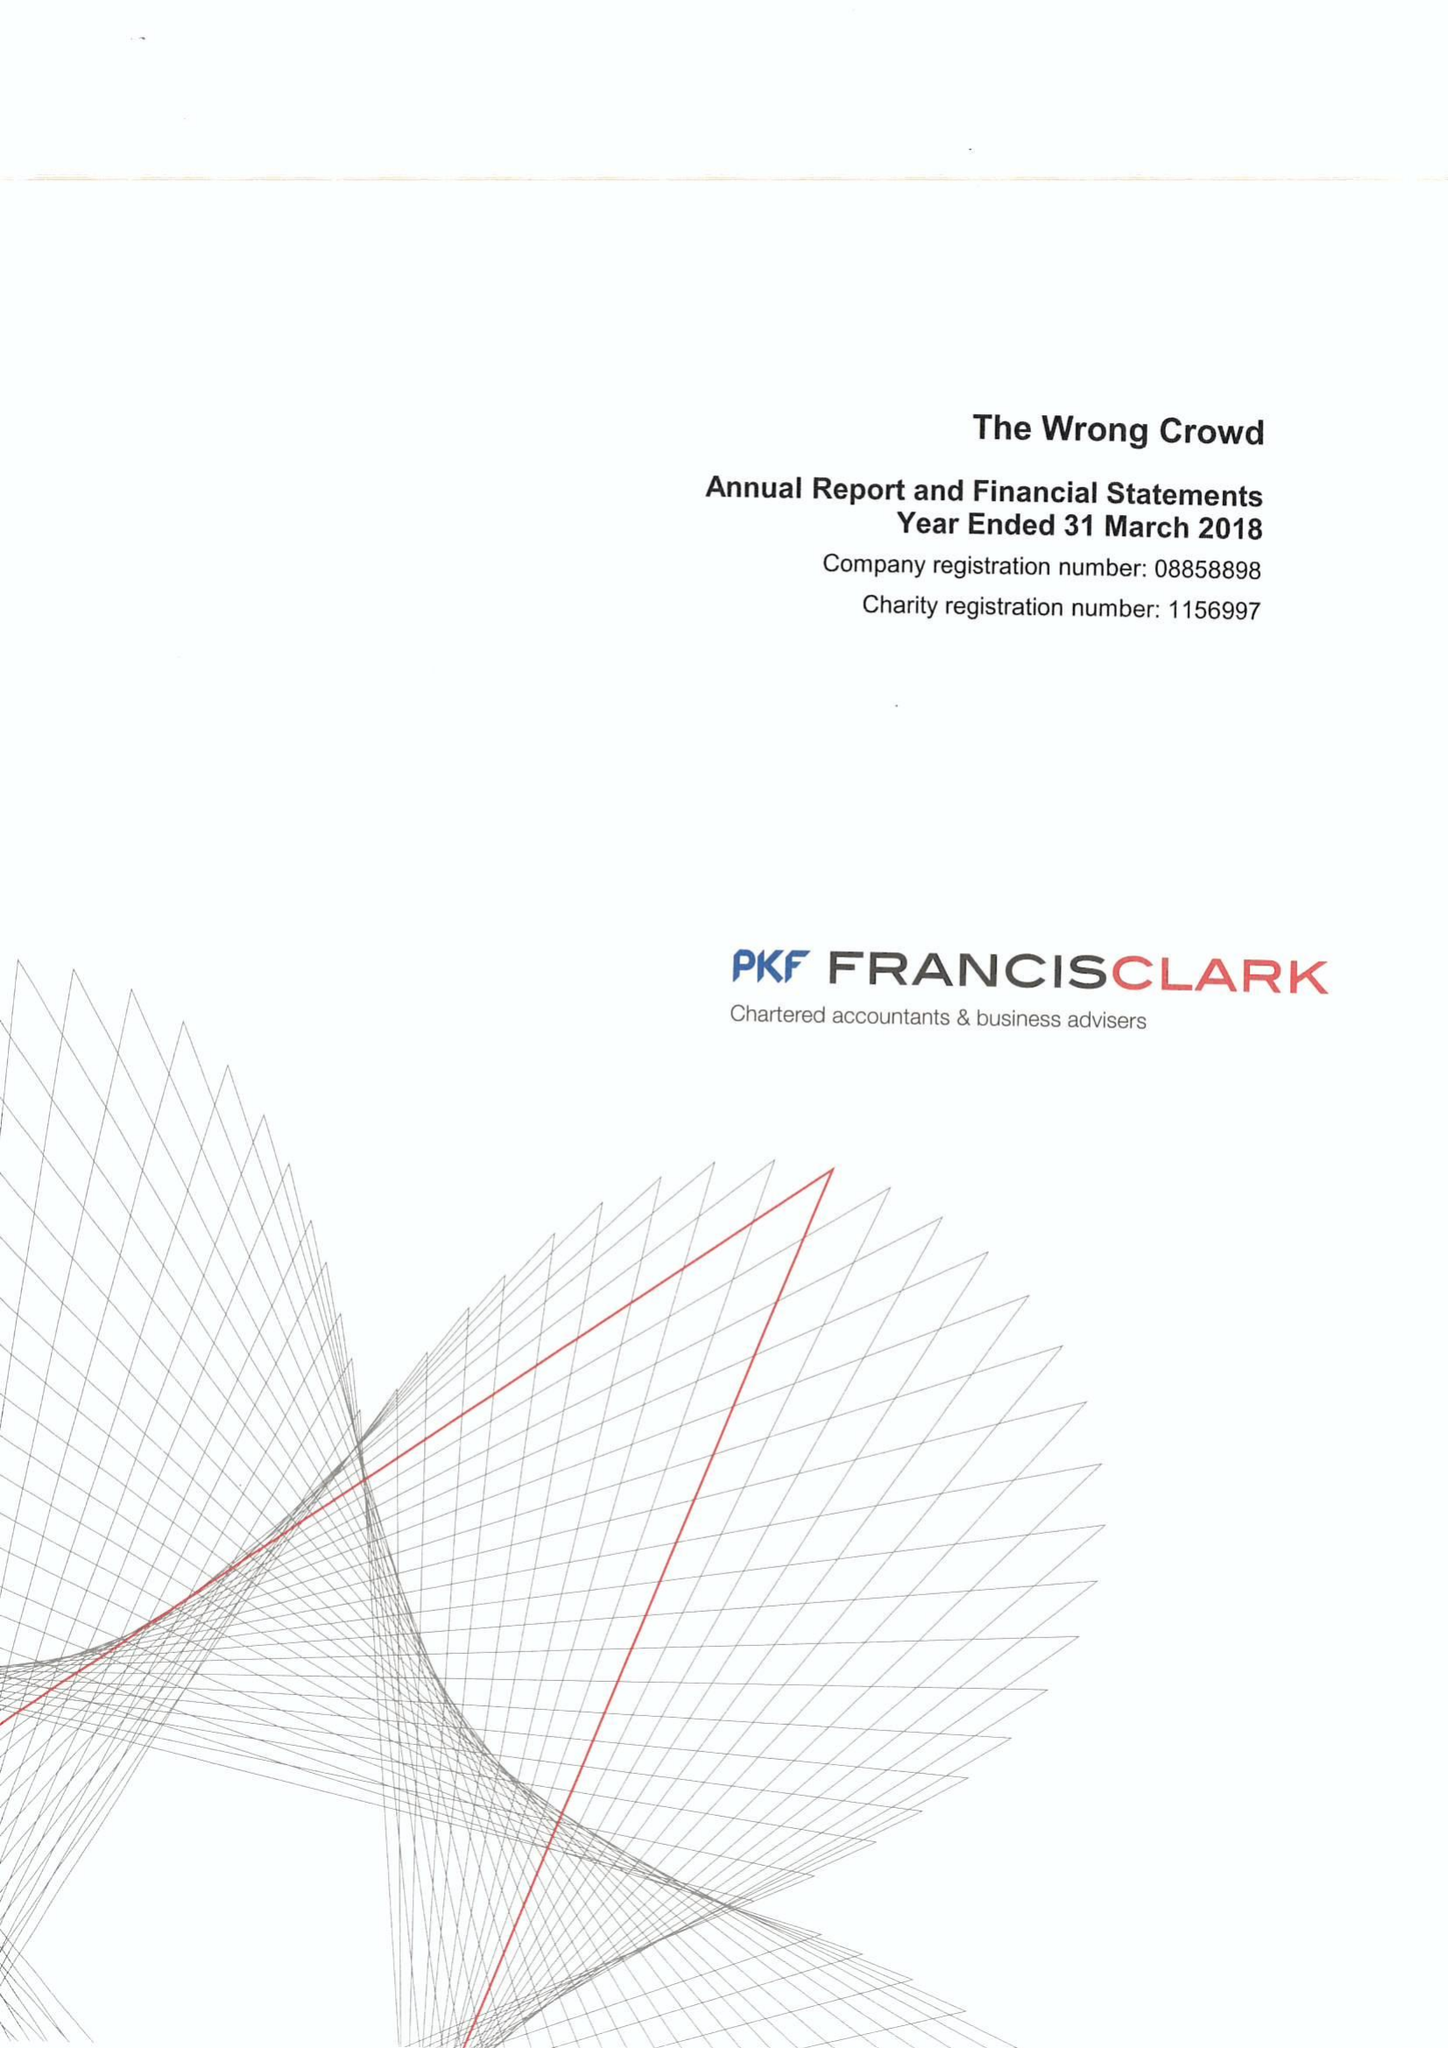What is the value for the address__post_town?
Answer the question using a single word or phrase. SOUTH BRENT 